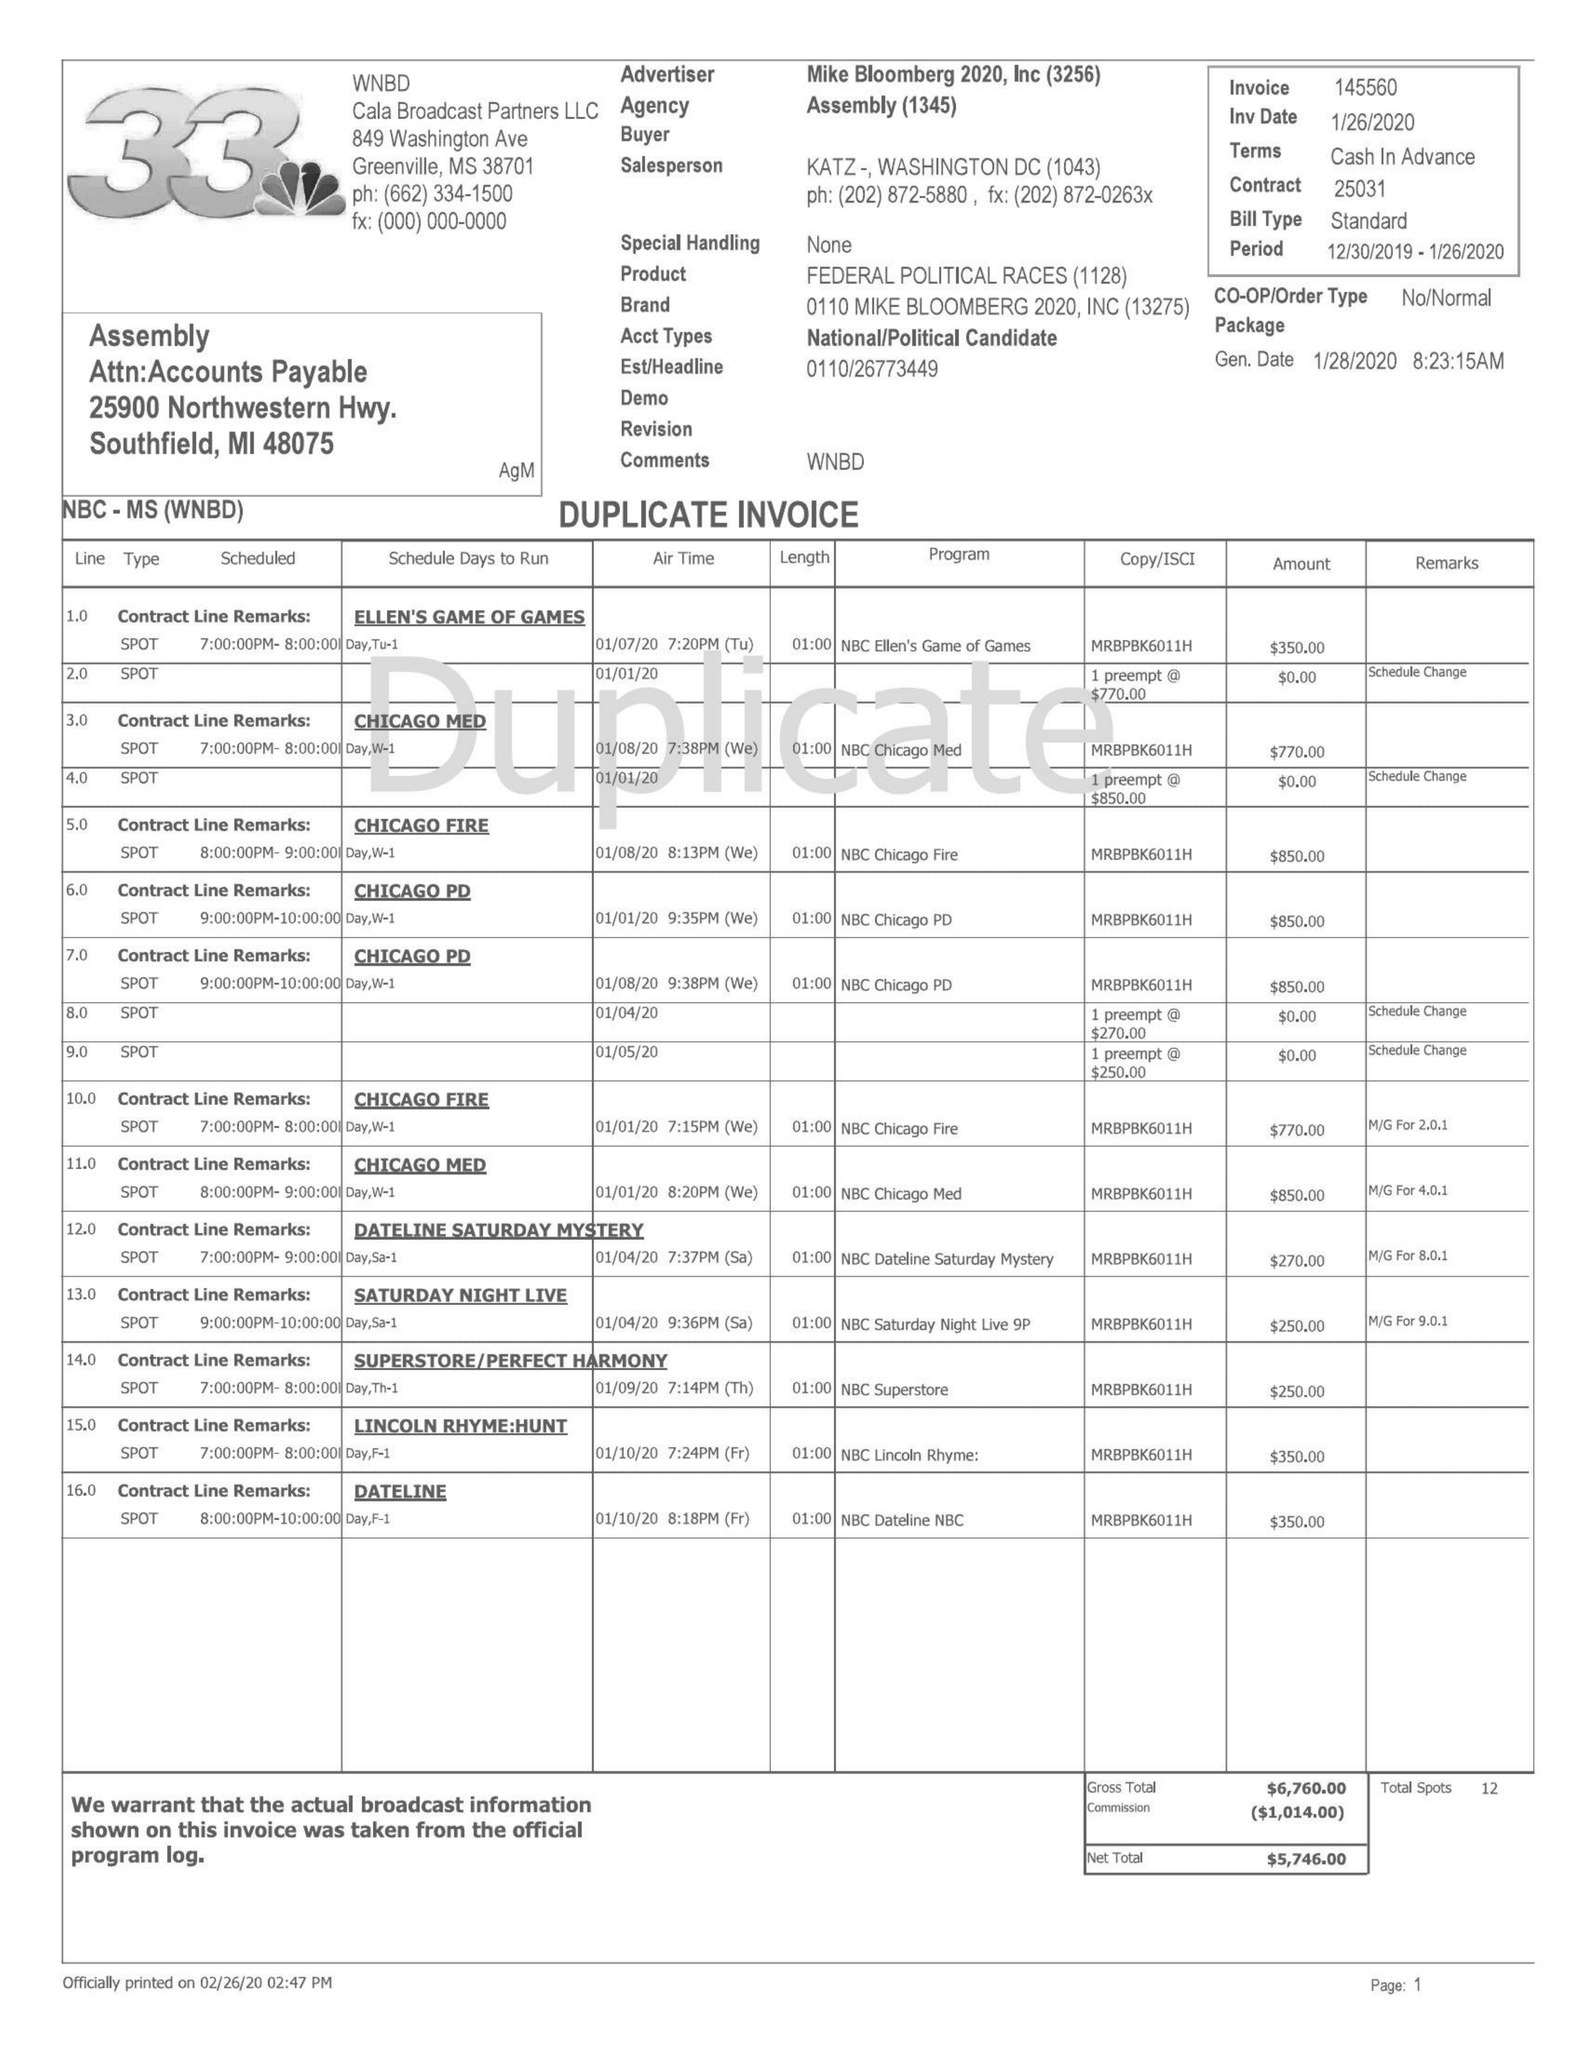What is the value for the flight_to?
Answer the question using a single word or phrase. 01/26/20 